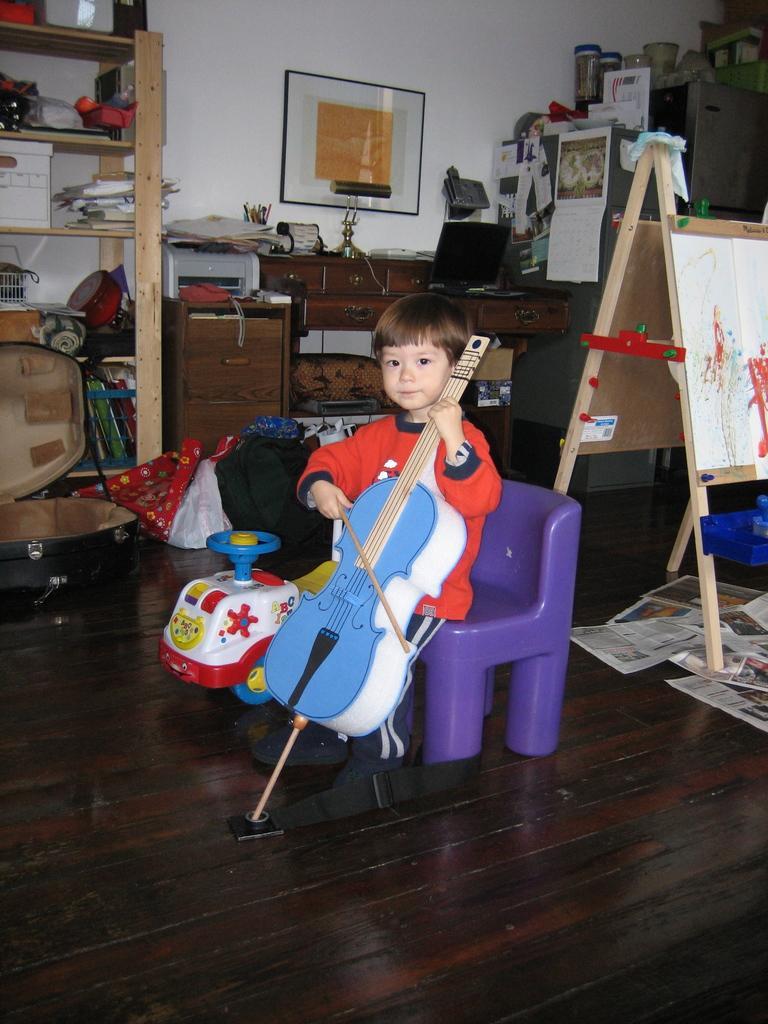Can you describe this image briefly? In this picture there is a boy who is playing violin. There is a toy car. Boy is sitting on the chair. There is a pot. There is a frame on the wall. There is a xerox machine on the desk. There is a rack at the corner. There are few bottles to the side. There are news papers on the floor. 